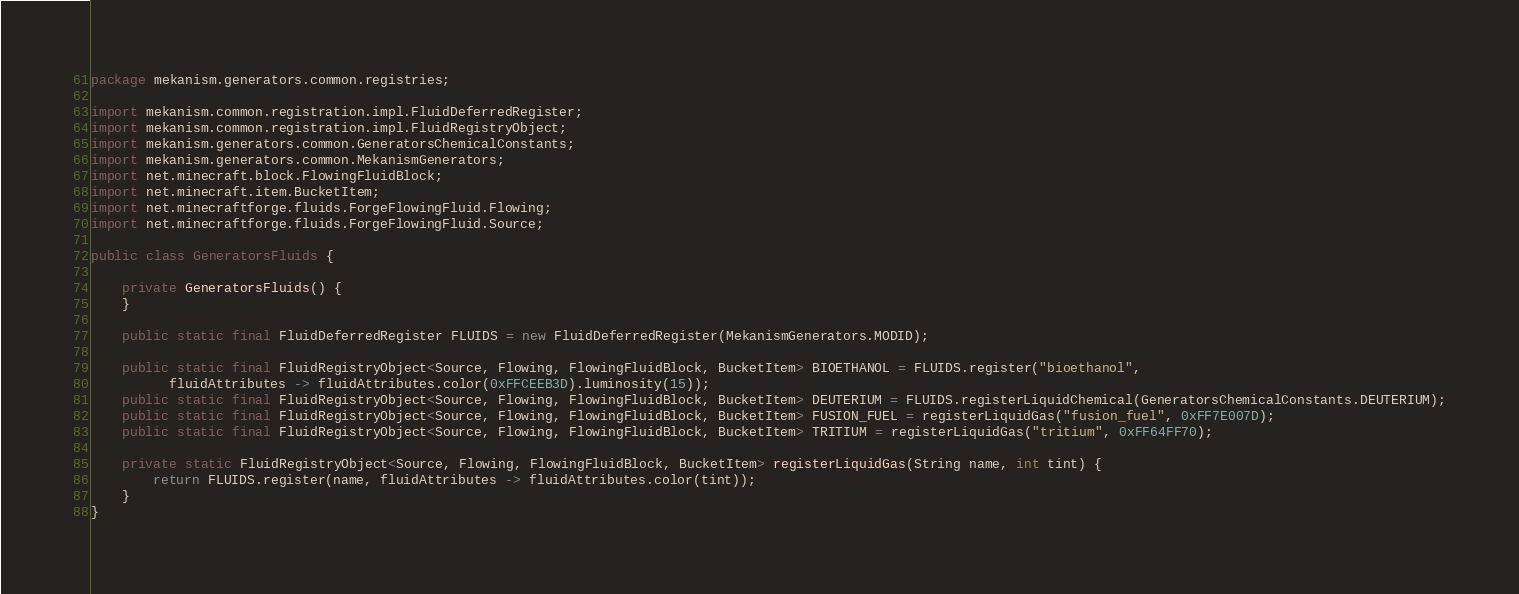Convert code to text. <code><loc_0><loc_0><loc_500><loc_500><_Java_>package mekanism.generators.common.registries;

import mekanism.common.registration.impl.FluidDeferredRegister;
import mekanism.common.registration.impl.FluidRegistryObject;
import mekanism.generators.common.GeneratorsChemicalConstants;
import mekanism.generators.common.MekanismGenerators;
import net.minecraft.block.FlowingFluidBlock;
import net.minecraft.item.BucketItem;
import net.minecraftforge.fluids.ForgeFlowingFluid.Flowing;
import net.minecraftforge.fluids.ForgeFlowingFluid.Source;

public class GeneratorsFluids {

    private GeneratorsFluids() {
    }

    public static final FluidDeferredRegister FLUIDS = new FluidDeferredRegister(MekanismGenerators.MODID);

    public static final FluidRegistryObject<Source, Flowing, FlowingFluidBlock, BucketItem> BIOETHANOL = FLUIDS.register("bioethanol",
          fluidAttributes -> fluidAttributes.color(0xFFCEEB3D).luminosity(15));
    public static final FluidRegistryObject<Source, Flowing, FlowingFluidBlock, BucketItem> DEUTERIUM = FLUIDS.registerLiquidChemical(GeneratorsChemicalConstants.DEUTERIUM);
    public static final FluidRegistryObject<Source, Flowing, FlowingFluidBlock, BucketItem> FUSION_FUEL = registerLiquidGas("fusion_fuel", 0xFF7E007D);
    public static final FluidRegistryObject<Source, Flowing, FlowingFluidBlock, BucketItem> TRITIUM = registerLiquidGas("tritium", 0xFF64FF70);

    private static FluidRegistryObject<Source, Flowing, FlowingFluidBlock, BucketItem> registerLiquidGas(String name, int tint) {
        return FLUIDS.register(name, fluidAttributes -> fluidAttributes.color(tint));
    }
}</code> 